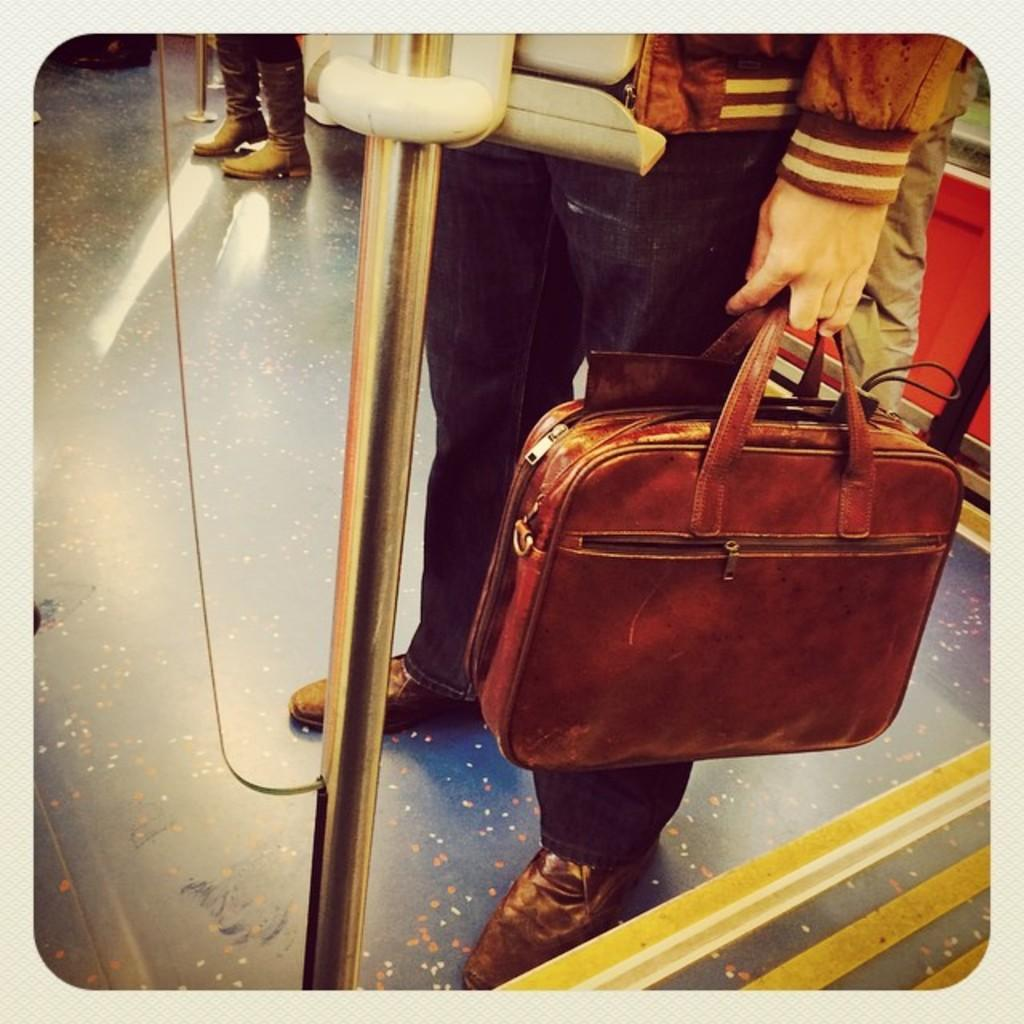What can be seen in the image? There is a man in the image. What is the man holding? The man is holding a bag. Where might this image have been taken? The image appears to be taken inside a train. What type of coast can be seen through the window in the image? There is no window or coast visible in the image; it is focused on a man holding a bag inside a train. 